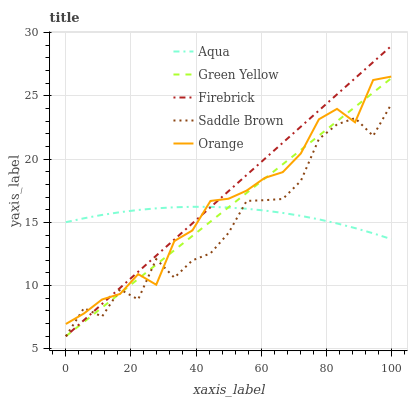Does Saddle Brown have the minimum area under the curve?
Answer yes or no. Yes. Does Firebrick have the maximum area under the curve?
Answer yes or no. Yes. Does Green Yellow have the minimum area under the curve?
Answer yes or no. No. Does Green Yellow have the maximum area under the curve?
Answer yes or no. No. Is Firebrick the smoothest?
Answer yes or no. Yes. Is Saddle Brown the roughest?
Answer yes or no. Yes. Is Green Yellow the smoothest?
Answer yes or no. No. Is Green Yellow the roughest?
Answer yes or no. No. Does Firebrick have the lowest value?
Answer yes or no. Yes. Does Aqua have the lowest value?
Answer yes or no. No. Does Firebrick have the highest value?
Answer yes or no. Yes. Does Green Yellow have the highest value?
Answer yes or no. No. Does Orange intersect Saddle Brown?
Answer yes or no. Yes. Is Orange less than Saddle Brown?
Answer yes or no. No. Is Orange greater than Saddle Brown?
Answer yes or no. No. 